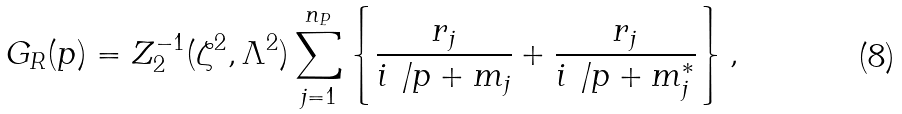<formula> <loc_0><loc_0><loc_500><loc_500>G _ { R } ( p ) = Z _ { 2 } ^ { - 1 } ( \zeta ^ { 2 } , \Lambda ^ { 2 } ) \sum _ { j = 1 } ^ { n _ { P } } \left \{ \frac { r _ { j } } { i \not \, p + m _ { j } } + \frac { r _ { j } } { i \not \, p + m _ { j } ^ { * } } \right \} ,</formula> 